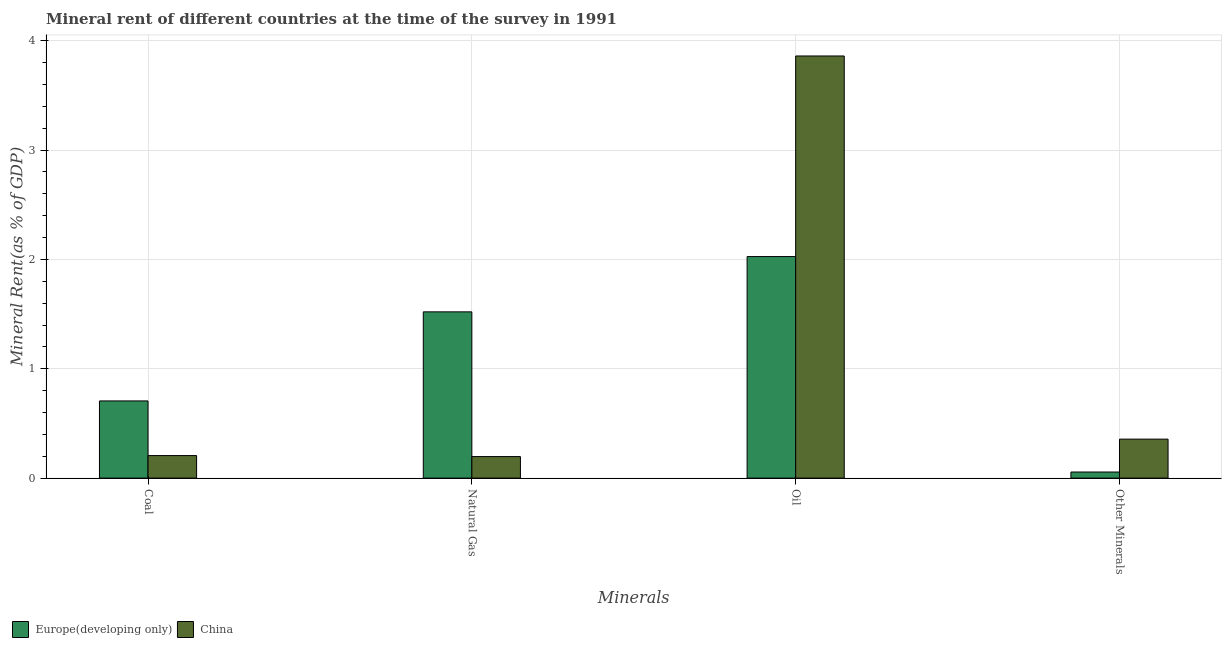How many different coloured bars are there?
Provide a succinct answer. 2. How many bars are there on the 2nd tick from the left?
Your answer should be very brief. 2. What is the label of the 4th group of bars from the left?
Ensure brevity in your answer.  Other Minerals. What is the  rent of other minerals in China?
Provide a short and direct response. 0.36. Across all countries, what is the maximum oil rent?
Provide a succinct answer. 3.86. Across all countries, what is the minimum  rent of other minerals?
Offer a terse response. 0.06. What is the total natural gas rent in the graph?
Make the answer very short. 1.72. What is the difference between the  rent of other minerals in China and that in Europe(developing only)?
Your answer should be very brief. 0.3. What is the difference between the natural gas rent in Europe(developing only) and the  rent of other minerals in China?
Keep it short and to the point. 1.16. What is the average  rent of other minerals per country?
Your response must be concise. 0.21. What is the difference between the natural gas rent and coal rent in Europe(developing only)?
Give a very brief answer. 0.81. What is the ratio of the coal rent in China to that in Europe(developing only)?
Your answer should be compact. 0.29. Is the coal rent in China less than that in Europe(developing only)?
Give a very brief answer. Yes. Is the difference between the  rent of other minerals in China and Europe(developing only) greater than the difference between the oil rent in China and Europe(developing only)?
Your answer should be compact. No. What is the difference between the highest and the second highest oil rent?
Provide a succinct answer. 1.83. What is the difference between the highest and the lowest natural gas rent?
Give a very brief answer. 1.32. In how many countries, is the oil rent greater than the average oil rent taken over all countries?
Ensure brevity in your answer.  1. What does the 2nd bar from the left in Other Minerals represents?
Your response must be concise. China. What does the 1st bar from the right in Coal represents?
Offer a very short reply. China. Is it the case that in every country, the sum of the coal rent and natural gas rent is greater than the oil rent?
Provide a short and direct response. No. Are all the bars in the graph horizontal?
Offer a terse response. No. How many countries are there in the graph?
Your answer should be compact. 2. What is the difference between two consecutive major ticks on the Y-axis?
Provide a short and direct response. 1. Where does the legend appear in the graph?
Make the answer very short. Bottom left. How are the legend labels stacked?
Give a very brief answer. Horizontal. What is the title of the graph?
Offer a very short reply. Mineral rent of different countries at the time of the survey in 1991. Does "Belgium" appear as one of the legend labels in the graph?
Provide a succinct answer. No. What is the label or title of the X-axis?
Your answer should be compact. Minerals. What is the label or title of the Y-axis?
Your answer should be compact. Mineral Rent(as % of GDP). What is the Mineral Rent(as % of GDP) of Europe(developing only) in Coal?
Make the answer very short. 0.71. What is the Mineral Rent(as % of GDP) of China in Coal?
Offer a terse response. 0.21. What is the Mineral Rent(as % of GDP) in Europe(developing only) in Natural Gas?
Ensure brevity in your answer.  1.52. What is the Mineral Rent(as % of GDP) of China in Natural Gas?
Offer a terse response. 0.2. What is the Mineral Rent(as % of GDP) of Europe(developing only) in Oil?
Keep it short and to the point. 2.03. What is the Mineral Rent(as % of GDP) of China in Oil?
Your answer should be very brief. 3.86. What is the Mineral Rent(as % of GDP) in Europe(developing only) in Other Minerals?
Your answer should be compact. 0.06. What is the Mineral Rent(as % of GDP) of China in Other Minerals?
Offer a very short reply. 0.36. Across all Minerals, what is the maximum Mineral Rent(as % of GDP) of Europe(developing only)?
Provide a short and direct response. 2.03. Across all Minerals, what is the maximum Mineral Rent(as % of GDP) in China?
Make the answer very short. 3.86. Across all Minerals, what is the minimum Mineral Rent(as % of GDP) of Europe(developing only)?
Provide a succinct answer. 0.06. Across all Minerals, what is the minimum Mineral Rent(as % of GDP) in China?
Your answer should be very brief. 0.2. What is the total Mineral Rent(as % of GDP) of Europe(developing only) in the graph?
Keep it short and to the point. 4.31. What is the total Mineral Rent(as % of GDP) in China in the graph?
Provide a succinct answer. 4.62. What is the difference between the Mineral Rent(as % of GDP) in Europe(developing only) in Coal and that in Natural Gas?
Give a very brief answer. -0.81. What is the difference between the Mineral Rent(as % of GDP) in China in Coal and that in Natural Gas?
Ensure brevity in your answer.  0.01. What is the difference between the Mineral Rent(as % of GDP) of Europe(developing only) in Coal and that in Oil?
Provide a short and direct response. -1.32. What is the difference between the Mineral Rent(as % of GDP) in China in Coal and that in Oil?
Your answer should be compact. -3.65. What is the difference between the Mineral Rent(as % of GDP) in Europe(developing only) in Coal and that in Other Minerals?
Provide a short and direct response. 0.65. What is the difference between the Mineral Rent(as % of GDP) in China in Coal and that in Other Minerals?
Keep it short and to the point. -0.15. What is the difference between the Mineral Rent(as % of GDP) in Europe(developing only) in Natural Gas and that in Oil?
Ensure brevity in your answer.  -0.51. What is the difference between the Mineral Rent(as % of GDP) in China in Natural Gas and that in Oil?
Your answer should be compact. -3.66. What is the difference between the Mineral Rent(as % of GDP) of Europe(developing only) in Natural Gas and that in Other Minerals?
Your answer should be compact. 1.47. What is the difference between the Mineral Rent(as % of GDP) in China in Natural Gas and that in Other Minerals?
Ensure brevity in your answer.  -0.16. What is the difference between the Mineral Rent(as % of GDP) of Europe(developing only) in Oil and that in Other Minerals?
Make the answer very short. 1.97. What is the difference between the Mineral Rent(as % of GDP) in China in Oil and that in Other Minerals?
Your response must be concise. 3.5. What is the difference between the Mineral Rent(as % of GDP) of Europe(developing only) in Coal and the Mineral Rent(as % of GDP) of China in Natural Gas?
Your response must be concise. 0.51. What is the difference between the Mineral Rent(as % of GDP) in Europe(developing only) in Coal and the Mineral Rent(as % of GDP) in China in Oil?
Your answer should be very brief. -3.15. What is the difference between the Mineral Rent(as % of GDP) of Europe(developing only) in Coal and the Mineral Rent(as % of GDP) of China in Other Minerals?
Make the answer very short. 0.35. What is the difference between the Mineral Rent(as % of GDP) in Europe(developing only) in Natural Gas and the Mineral Rent(as % of GDP) in China in Oil?
Offer a terse response. -2.34. What is the difference between the Mineral Rent(as % of GDP) of Europe(developing only) in Natural Gas and the Mineral Rent(as % of GDP) of China in Other Minerals?
Provide a succinct answer. 1.16. What is the difference between the Mineral Rent(as % of GDP) of Europe(developing only) in Oil and the Mineral Rent(as % of GDP) of China in Other Minerals?
Your answer should be very brief. 1.67. What is the average Mineral Rent(as % of GDP) in Europe(developing only) per Minerals?
Your answer should be very brief. 1.08. What is the average Mineral Rent(as % of GDP) of China per Minerals?
Make the answer very short. 1.16. What is the difference between the Mineral Rent(as % of GDP) in Europe(developing only) and Mineral Rent(as % of GDP) in China in Coal?
Your answer should be very brief. 0.5. What is the difference between the Mineral Rent(as % of GDP) in Europe(developing only) and Mineral Rent(as % of GDP) in China in Natural Gas?
Ensure brevity in your answer.  1.32. What is the difference between the Mineral Rent(as % of GDP) of Europe(developing only) and Mineral Rent(as % of GDP) of China in Oil?
Provide a succinct answer. -1.83. What is the difference between the Mineral Rent(as % of GDP) of Europe(developing only) and Mineral Rent(as % of GDP) of China in Other Minerals?
Provide a succinct answer. -0.3. What is the ratio of the Mineral Rent(as % of GDP) in Europe(developing only) in Coal to that in Natural Gas?
Provide a succinct answer. 0.46. What is the ratio of the Mineral Rent(as % of GDP) in China in Coal to that in Natural Gas?
Make the answer very short. 1.05. What is the ratio of the Mineral Rent(as % of GDP) in Europe(developing only) in Coal to that in Oil?
Your answer should be compact. 0.35. What is the ratio of the Mineral Rent(as % of GDP) of China in Coal to that in Oil?
Offer a very short reply. 0.05. What is the ratio of the Mineral Rent(as % of GDP) of Europe(developing only) in Coal to that in Other Minerals?
Make the answer very short. 12.66. What is the ratio of the Mineral Rent(as % of GDP) in China in Coal to that in Other Minerals?
Your answer should be very brief. 0.58. What is the ratio of the Mineral Rent(as % of GDP) of Europe(developing only) in Natural Gas to that in Oil?
Offer a very short reply. 0.75. What is the ratio of the Mineral Rent(as % of GDP) of China in Natural Gas to that in Oil?
Your answer should be very brief. 0.05. What is the ratio of the Mineral Rent(as % of GDP) in Europe(developing only) in Natural Gas to that in Other Minerals?
Keep it short and to the point. 27.26. What is the ratio of the Mineral Rent(as % of GDP) in China in Natural Gas to that in Other Minerals?
Offer a very short reply. 0.55. What is the ratio of the Mineral Rent(as % of GDP) in Europe(developing only) in Oil to that in Other Minerals?
Offer a very short reply. 36.33. What is the ratio of the Mineral Rent(as % of GDP) in China in Oil to that in Other Minerals?
Give a very brief answer. 10.83. What is the difference between the highest and the second highest Mineral Rent(as % of GDP) in Europe(developing only)?
Offer a very short reply. 0.51. What is the difference between the highest and the second highest Mineral Rent(as % of GDP) of China?
Make the answer very short. 3.5. What is the difference between the highest and the lowest Mineral Rent(as % of GDP) of Europe(developing only)?
Offer a terse response. 1.97. What is the difference between the highest and the lowest Mineral Rent(as % of GDP) of China?
Ensure brevity in your answer.  3.66. 